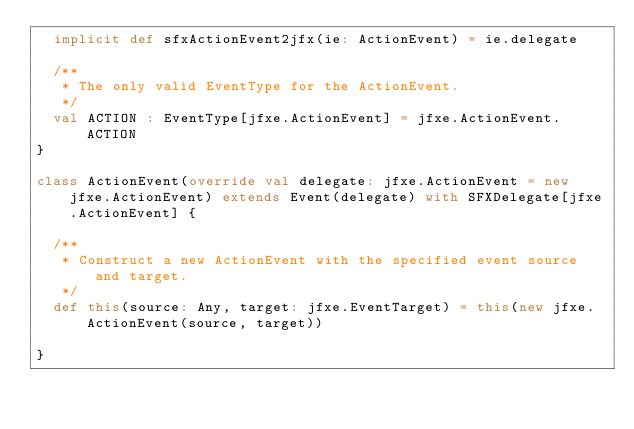Convert code to text. <code><loc_0><loc_0><loc_500><loc_500><_Scala_>  implicit def sfxActionEvent2jfx(ie: ActionEvent) = ie.delegate
  
  /**
   * The only valid EventType for the ActionEvent.
   */
  val ACTION : EventType[jfxe.ActionEvent] = jfxe.ActionEvent.ACTION
}

class ActionEvent(override val delegate: jfxe.ActionEvent = new jfxe.ActionEvent) extends Event(delegate) with SFXDelegate[jfxe.ActionEvent] {

  /**
   * Construct a new ActionEvent with the specified event source and target.
   */
  def this(source: Any, target: jfxe.EventTarget) = this(new jfxe.ActionEvent(source, target))

}</code> 